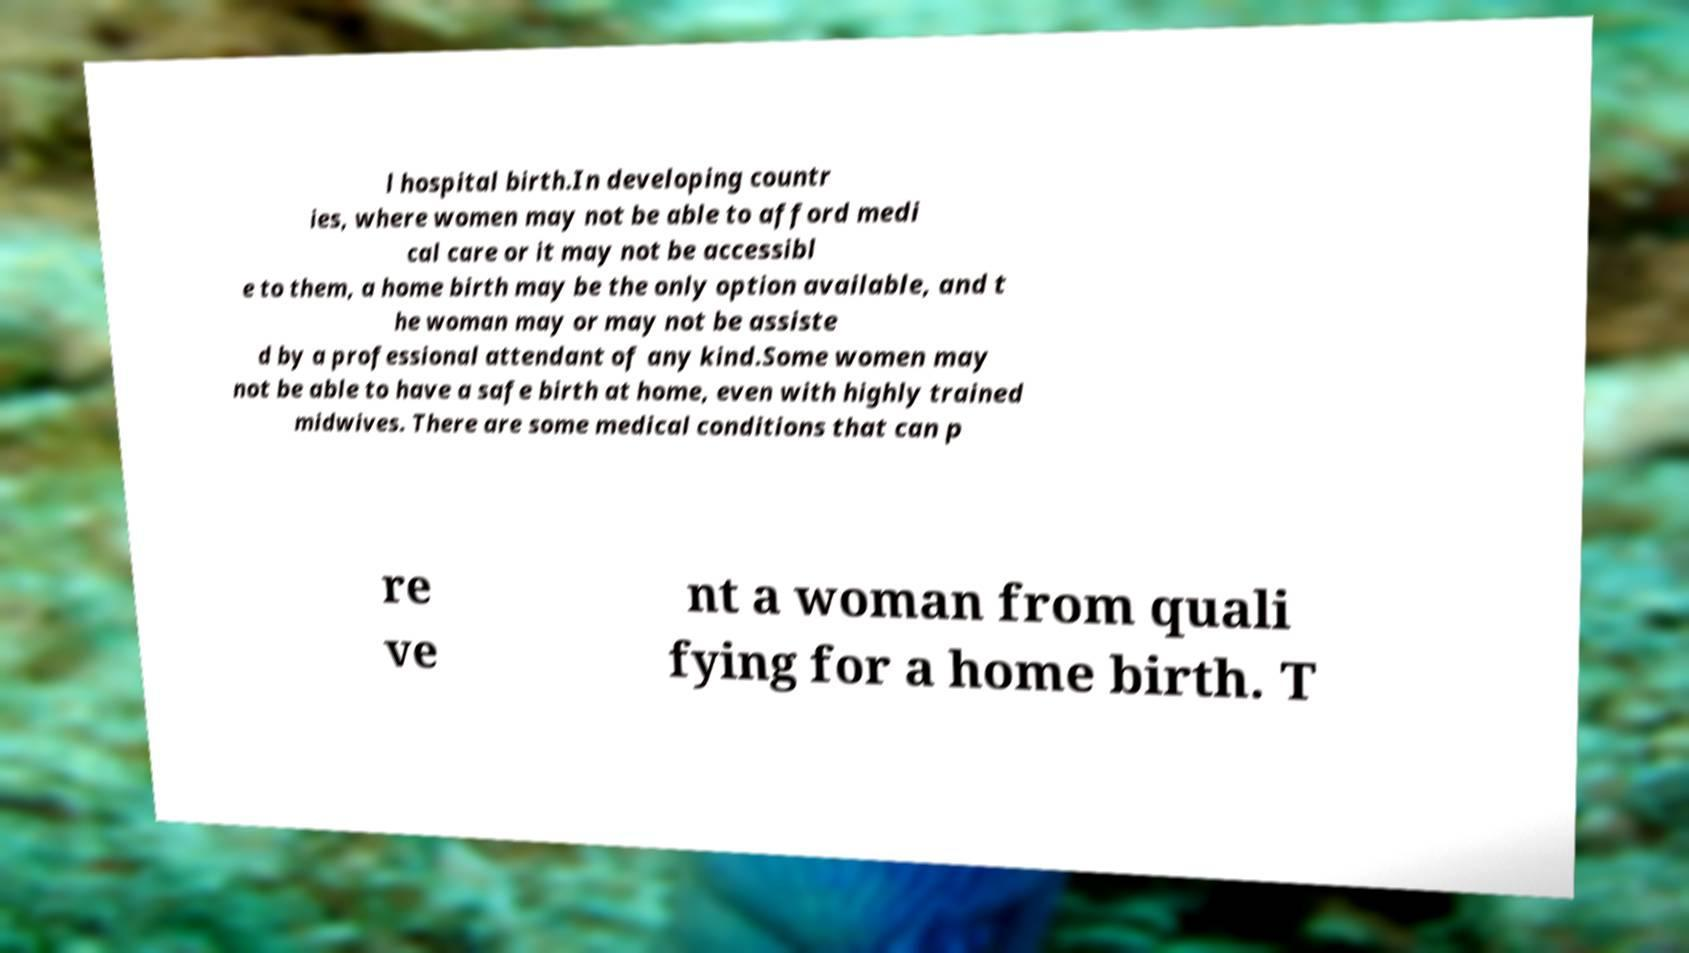Please read and relay the text visible in this image. What does it say? l hospital birth.In developing countr ies, where women may not be able to afford medi cal care or it may not be accessibl e to them, a home birth may be the only option available, and t he woman may or may not be assiste d by a professional attendant of any kind.Some women may not be able to have a safe birth at home, even with highly trained midwives. There are some medical conditions that can p re ve nt a woman from quali fying for a home birth. T 